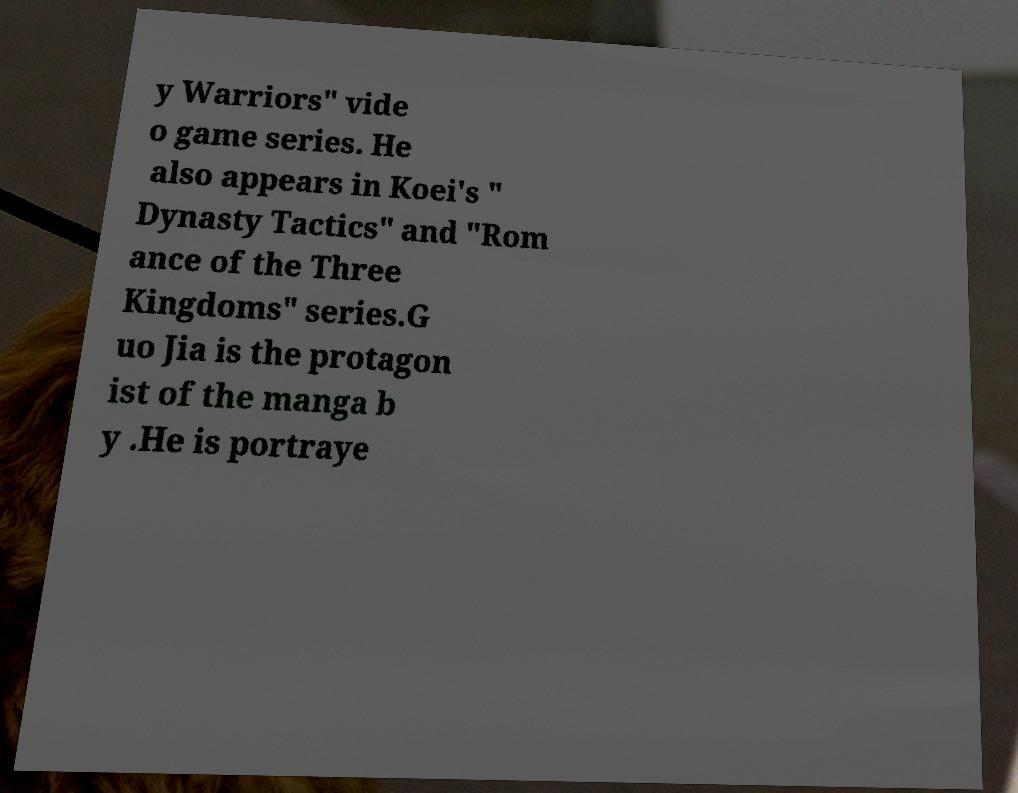I need the written content from this picture converted into text. Can you do that? y Warriors" vide o game series. He also appears in Koei's " Dynasty Tactics" and "Rom ance of the Three Kingdoms" series.G uo Jia is the protagon ist of the manga b y .He is portraye 